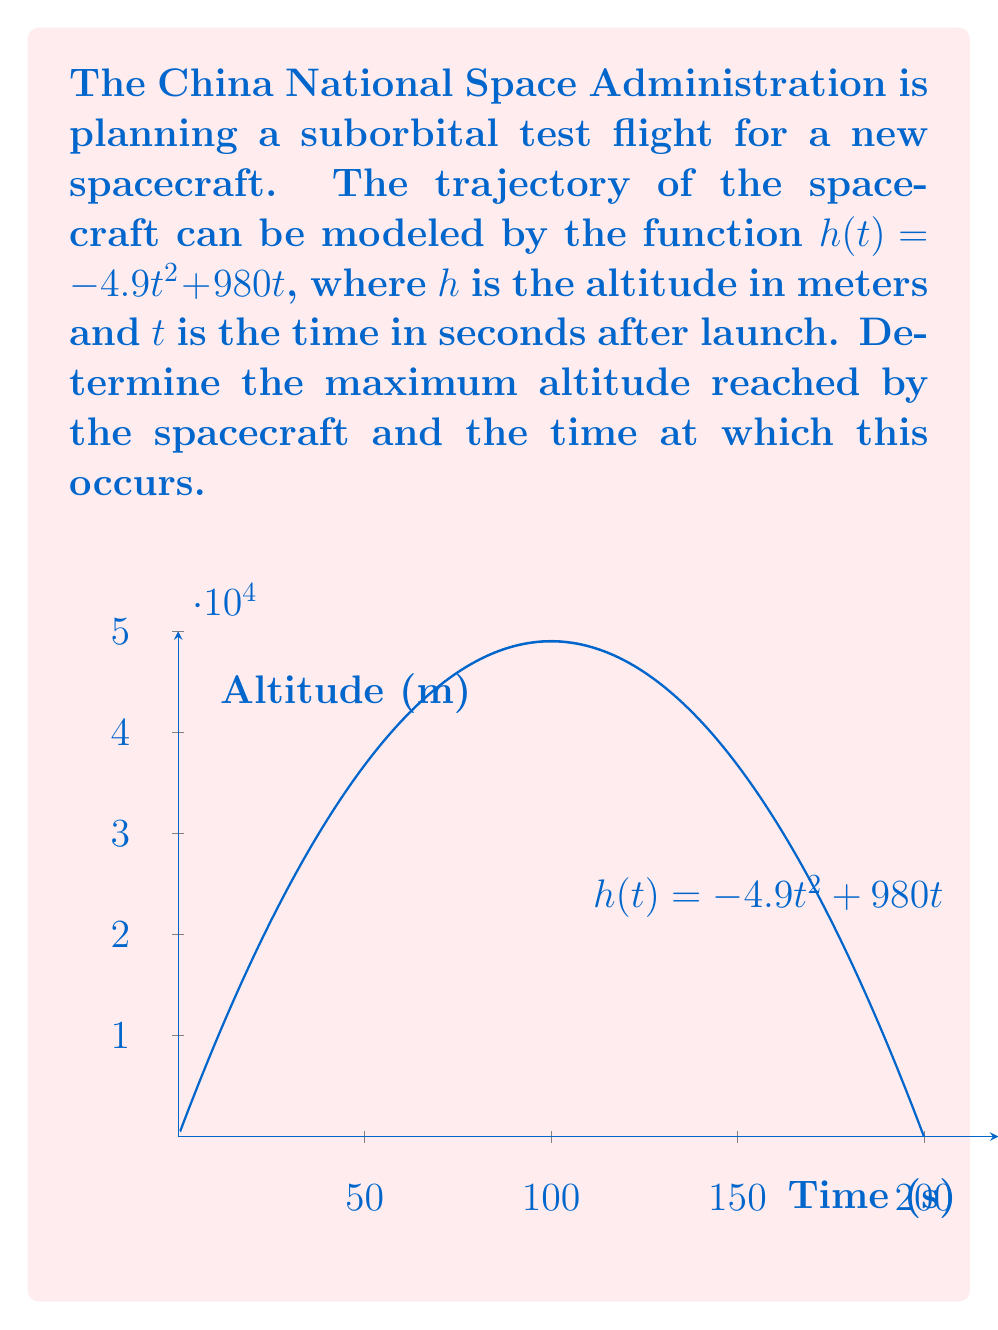Could you help me with this problem? To find the maximum altitude, we need to determine the critical point of the function $h(t)$ and verify it's a maximum.

Step 1: Find the derivative of $h(t)$.
$$h'(t) = -9.8t + 980$$

Step 2: Set the derivative equal to zero and solve for $t$.
$$\begin{align}
-9.8t + 980 &= 0 \\
-9.8t &= -980 \\
t &= 100
\end{align}$$

Step 3: Verify this critical point is a maximum by checking the second derivative.
$$h''(t) = -9.8$$
Since $h''(t)$ is negative for all $t$, the critical point at $t=100$ is indeed a maximum.

Step 4: Calculate the maximum altitude by plugging $t=100$ into the original function.
$$\begin{align}
h(100) &= -4.9(100)^2 + 980(100) \\
&= -49000 + 98000 \\
&= 49000
\end{align}$$

Therefore, the spacecraft reaches its maximum altitude of 49,000 meters at 100 seconds after launch.
Answer: Maximum altitude: 49,000 meters at t = 100 seconds 